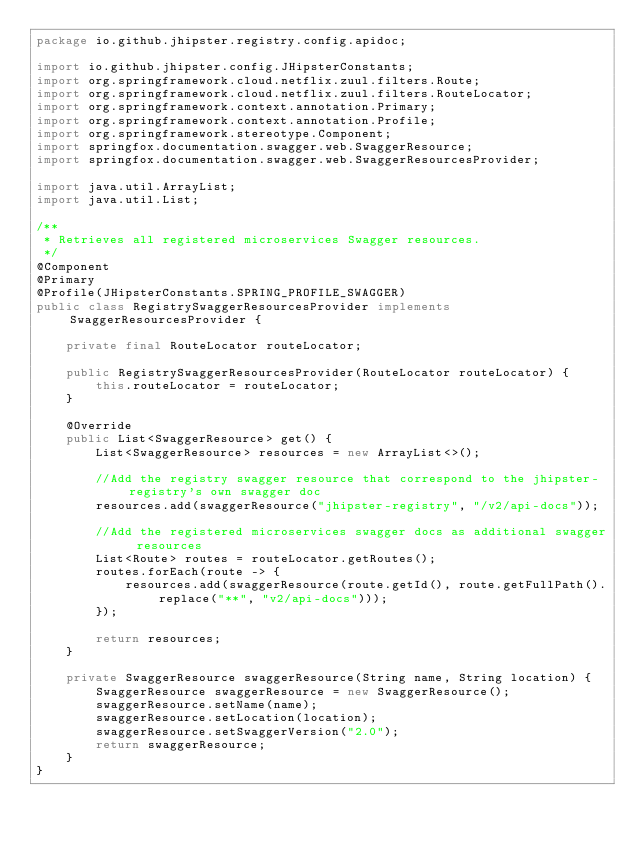<code> <loc_0><loc_0><loc_500><loc_500><_Java_>package io.github.jhipster.registry.config.apidoc;

import io.github.jhipster.config.JHipsterConstants;
import org.springframework.cloud.netflix.zuul.filters.Route;
import org.springframework.cloud.netflix.zuul.filters.RouteLocator;
import org.springframework.context.annotation.Primary;
import org.springframework.context.annotation.Profile;
import org.springframework.stereotype.Component;
import springfox.documentation.swagger.web.SwaggerResource;
import springfox.documentation.swagger.web.SwaggerResourcesProvider;

import java.util.ArrayList;
import java.util.List;

/**
 * Retrieves all registered microservices Swagger resources.
 */
@Component
@Primary
@Profile(JHipsterConstants.SPRING_PROFILE_SWAGGER)
public class RegistrySwaggerResourcesProvider implements SwaggerResourcesProvider {

    private final RouteLocator routeLocator;

    public RegistrySwaggerResourcesProvider(RouteLocator routeLocator) {
        this.routeLocator = routeLocator;
    }

    @Override
    public List<SwaggerResource> get() {
        List<SwaggerResource> resources = new ArrayList<>();

        //Add the registry swagger resource that correspond to the jhipster-registry's own swagger doc
        resources.add(swaggerResource("jhipster-registry", "/v2/api-docs"));

        //Add the registered microservices swagger docs as additional swagger resources
        List<Route> routes = routeLocator.getRoutes();
        routes.forEach(route -> {
            resources.add(swaggerResource(route.getId(), route.getFullPath().replace("**", "v2/api-docs")));
        });

        return resources;
    }

    private SwaggerResource swaggerResource(String name, String location) {
        SwaggerResource swaggerResource = new SwaggerResource();
        swaggerResource.setName(name);
        swaggerResource.setLocation(location);
        swaggerResource.setSwaggerVersion("2.0");
        return swaggerResource;
    }
}
</code> 